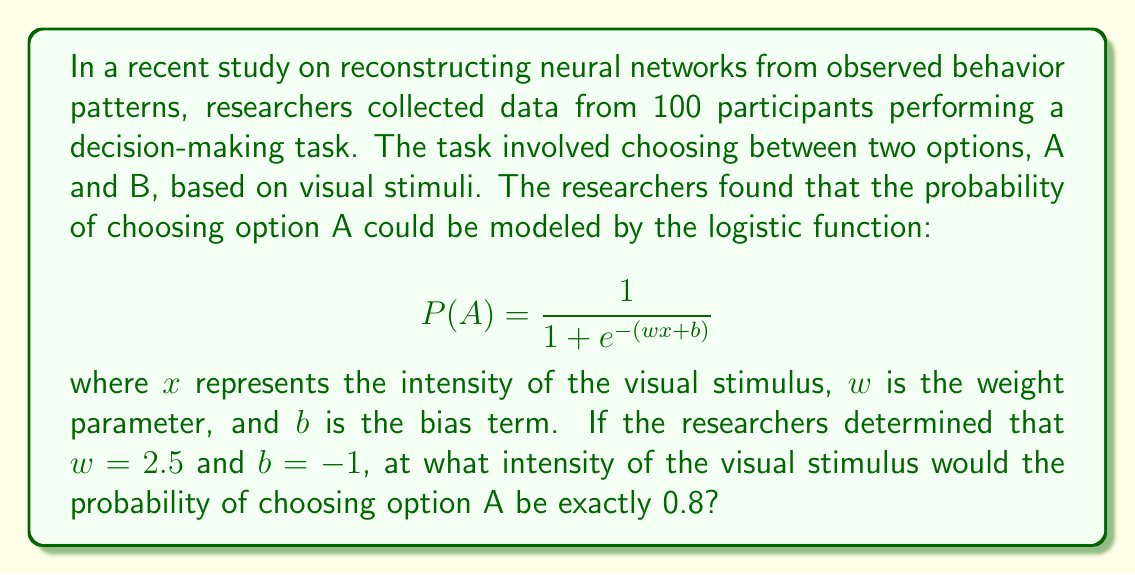Can you solve this math problem? To solve this problem, we need to follow these steps:

1. Start with the given logistic function:
   $$ P(A) = \frac{1}{1 + e^{-(wx + b)}} $$

2. Substitute the known values:
   $w = 2.5$, $b = -1$, and $P(A) = 0.8$
   $$ 0.8 = \frac{1}{1 + e^{-(2.5x - 1)}} $$

3. Solve for $x$:
   a) First, take the reciprocal of both sides:
      $$ \frac{1}{0.8} = 1 + e^{-(2.5x - 1)} $$
   
   b) Simplify:
      $$ 1.25 = 1 + e^{-(2.5x - 1)} $$
   
   c) Subtract 1 from both sides:
      $$ 0.25 = e^{-(2.5x - 1)} $$
   
   d) Take the natural logarithm of both sides:
      $$ \ln(0.25) = -(2.5x - 1) $$
   
   e) Simplify:
      $$ -1.386 = -(2.5x - 1) $$
   
   f) Multiply both sides by -1:
      $$ 1.386 = 2.5x - 1 $$
   
   g) Add 1 to both sides:
      $$ 2.386 = 2.5x $$
   
   h) Divide both sides by 2.5:
      $$ x = \frac{2.386}{2.5} = 0.9544 $$

Therefore, the intensity of the visual stimulus that would result in a probability of 0.8 for choosing option A is approximately 0.9544.
Answer: 0.9544 